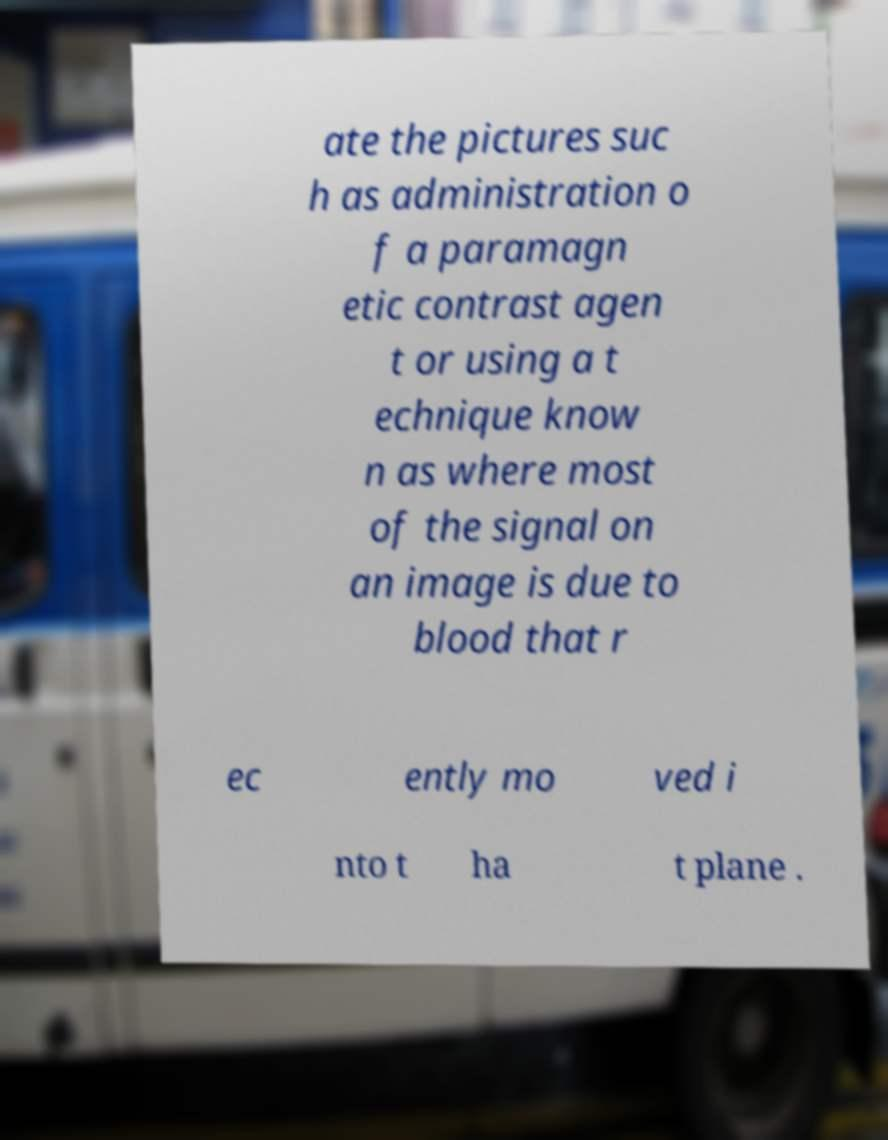For documentation purposes, I need the text within this image transcribed. Could you provide that? ate the pictures suc h as administration o f a paramagn etic contrast agen t or using a t echnique know n as where most of the signal on an image is due to blood that r ec ently mo ved i nto t ha t plane . 